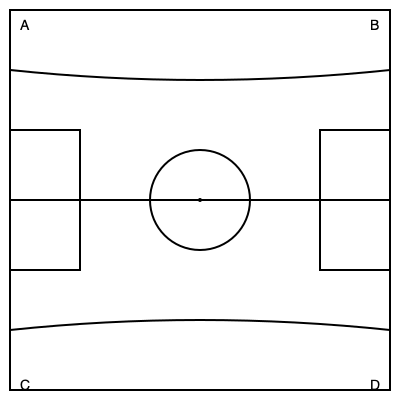As a former professional footballer, you're familiar with pitch markings. In this puzzle, you see various elements of a football pitch. If you were to rotate segment B 180 degrees clockwise around its center and then swap it with segment C, which key element of the pitch would be correctly positioned? 1. First, let's identify the segments:
   A: Top-left corner (correct position)
   B: Top-right corner (needs rotation and swapping)
   C: Bottom-left corner (needs swapping)
   D: Bottom-right corner (correct position)

2. Rotate segment B 180 degrees clockwise:
   - This will flip the penalty area and goal line to the bottom
   - The curved line (part of the center circle) will now be at the bottom

3. Swap rotated segment B with segment C:
   - The rotated B segment now occupies the bottom-left corner
   - The C segment now occupies the top-right corner

4. Analyze the result:
   - The penalty areas are now correctly positioned in both bottom corners
   - The goal lines are correctly positioned along the bottom
   - The center line remains correct
   - The center circle is now complete

5. Identify the key element:
   The center circle is the key element that becomes correctly positioned after these operations. It was incomplete before, but now forms a full circle at the center of the pitch.
Answer: Center circle 